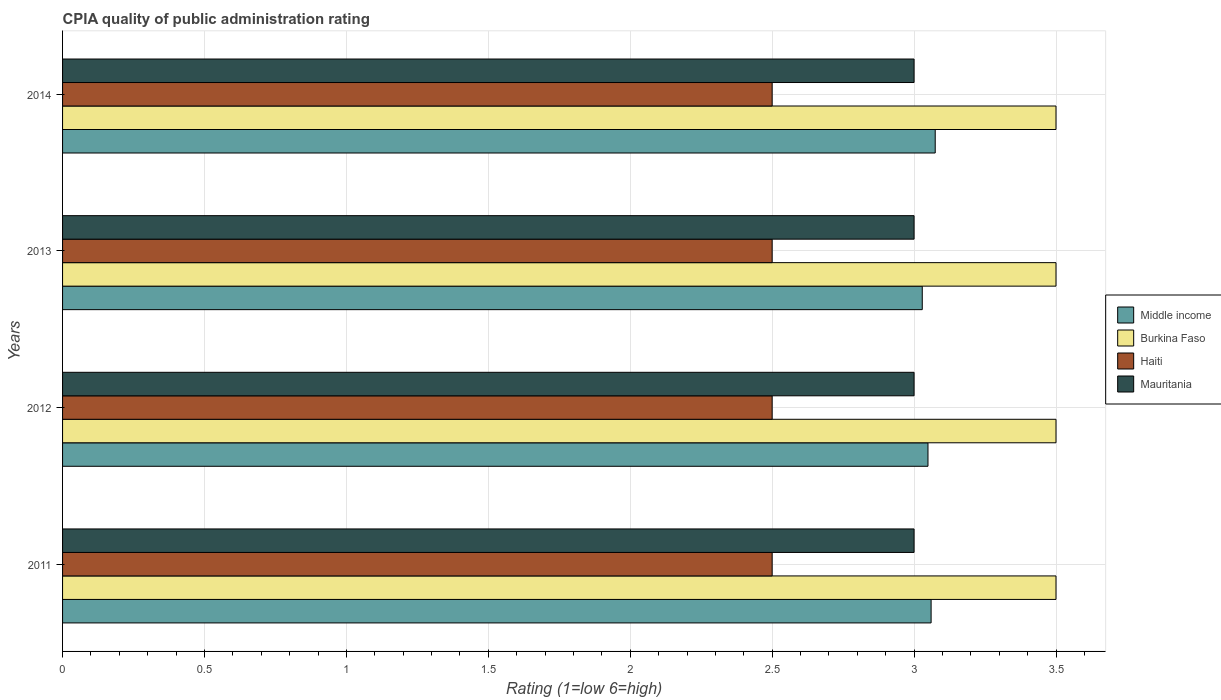How many different coloured bars are there?
Offer a very short reply. 4. How many groups of bars are there?
Give a very brief answer. 4. Are the number of bars on each tick of the Y-axis equal?
Keep it short and to the point. Yes. In how many cases, is the number of bars for a given year not equal to the number of legend labels?
Keep it short and to the point. 0. What is the CPIA rating in Mauritania in 2014?
Ensure brevity in your answer.  3. Across all years, what is the maximum CPIA rating in Haiti?
Keep it short and to the point. 2.5. Across all years, what is the minimum CPIA rating in Middle income?
Your response must be concise. 3.03. What is the total CPIA rating in Middle income in the graph?
Keep it short and to the point. 12.21. What is the difference between the CPIA rating in Middle income in 2013 and the CPIA rating in Burkina Faso in 2012?
Offer a very short reply. -0.47. What is the average CPIA rating in Burkina Faso per year?
Your answer should be very brief. 3.5. In how many years, is the CPIA rating in Mauritania greater than 2.6 ?
Give a very brief answer. 4. Is the difference between the CPIA rating in Burkina Faso in 2012 and 2013 greater than the difference between the CPIA rating in Haiti in 2012 and 2013?
Make the answer very short. No. In how many years, is the CPIA rating in Burkina Faso greater than the average CPIA rating in Burkina Faso taken over all years?
Offer a very short reply. 0. Is the sum of the CPIA rating in Middle income in 2012 and 2014 greater than the maximum CPIA rating in Burkina Faso across all years?
Ensure brevity in your answer.  Yes. What does the 1st bar from the top in 2011 represents?
Provide a short and direct response. Mauritania. What does the 4th bar from the bottom in 2011 represents?
Offer a terse response. Mauritania. Is it the case that in every year, the sum of the CPIA rating in Mauritania and CPIA rating in Middle income is greater than the CPIA rating in Haiti?
Give a very brief answer. Yes. Are the values on the major ticks of X-axis written in scientific E-notation?
Ensure brevity in your answer.  No. Does the graph contain grids?
Your response must be concise. Yes. How many legend labels are there?
Provide a succinct answer. 4. How are the legend labels stacked?
Keep it short and to the point. Vertical. What is the title of the graph?
Offer a very short reply. CPIA quality of public administration rating. Does "East Asia (all income levels)" appear as one of the legend labels in the graph?
Keep it short and to the point. No. What is the Rating (1=low 6=high) in Middle income in 2011?
Offer a very short reply. 3.06. What is the Rating (1=low 6=high) in Mauritania in 2011?
Your answer should be compact. 3. What is the Rating (1=low 6=high) in Middle income in 2012?
Offer a terse response. 3.05. What is the Rating (1=low 6=high) in Middle income in 2013?
Offer a very short reply. 3.03. What is the Rating (1=low 6=high) in Burkina Faso in 2013?
Provide a succinct answer. 3.5. What is the Rating (1=low 6=high) in Middle income in 2014?
Provide a short and direct response. 3.07. What is the Rating (1=low 6=high) in Mauritania in 2014?
Keep it short and to the point. 3. Across all years, what is the maximum Rating (1=low 6=high) of Middle income?
Keep it short and to the point. 3.07. Across all years, what is the minimum Rating (1=low 6=high) of Middle income?
Make the answer very short. 3.03. Across all years, what is the minimum Rating (1=low 6=high) in Burkina Faso?
Keep it short and to the point. 3.5. Across all years, what is the minimum Rating (1=low 6=high) in Mauritania?
Your answer should be compact. 3. What is the total Rating (1=low 6=high) of Middle income in the graph?
Provide a short and direct response. 12.21. What is the total Rating (1=low 6=high) in Burkina Faso in the graph?
Your response must be concise. 14. What is the total Rating (1=low 6=high) of Haiti in the graph?
Ensure brevity in your answer.  10. What is the total Rating (1=low 6=high) in Mauritania in the graph?
Offer a very short reply. 12. What is the difference between the Rating (1=low 6=high) of Middle income in 2011 and that in 2012?
Make the answer very short. 0.01. What is the difference between the Rating (1=low 6=high) in Burkina Faso in 2011 and that in 2012?
Provide a succinct answer. 0. What is the difference between the Rating (1=low 6=high) of Haiti in 2011 and that in 2012?
Ensure brevity in your answer.  0. What is the difference between the Rating (1=low 6=high) of Mauritania in 2011 and that in 2012?
Ensure brevity in your answer.  0. What is the difference between the Rating (1=low 6=high) in Middle income in 2011 and that in 2013?
Your answer should be compact. 0.03. What is the difference between the Rating (1=low 6=high) of Middle income in 2011 and that in 2014?
Provide a succinct answer. -0.01. What is the difference between the Rating (1=low 6=high) in Middle income in 2012 and that in 2013?
Provide a succinct answer. 0.02. What is the difference between the Rating (1=low 6=high) of Burkina Faso in 2012 and that in 2013?
Your response must be concise. 0. What is the difference between the Rating (1=low 6=high) of Haiti in 2012 and that in 2013?
Provide a succinct answer. 0. What is the difference between the Rating (1=low 6=high) in Middle income in 2012 and that in 2014?
Your response must be concise. -0.03. What is the difference between the Rating (1=low 6=high) of Burkina Faso in 2012 and that in 2014?
Your answer should be compact. 0. What is the difference between the Rating (1=low 6=high) of Haiti in 2012 and that in 2014?
Offer a terse response. 0. What is the difference between the Rating (1=low 6=high) of Middle income in 2013 and that in 2014?
Offer a very short reply. -0.05. What is the difference between the Rating (1=low 6=high) in Mauritania in 2013 and that in 2014?
Your response must be concise. 0. What is the difference between the Rating (1=low 6=high) of Middle income in 2011 and the Rating (1=low 6=high) of Burkina Faso in 2012?
Make the answer very short. -0.44. What is the difference between the Rating (1=low 6=high) in Middle income in 2011 and the Rating (1=low 6=high) in Haiti in 2012?
Your answer should be compact. 0.56. What is the difference between the Rating (1=low 6=high) of Burkina Faso in 2011 and the Rating (1=low 6=high) of Mauritania in 2012?
Your answer should be compact. 0.5. What is the difference between the Rating (1=low 6=high) of Middle income in 2011 and the Rating (1=low 6=high) of Burkina Faso in 2013?
Your answer should be very brief. -0.44. What is the difference between the Rating (1=low 6=high) of Middle income in 2011 and the Rating (1=low 6=high) of Haiti in 2013?
Make the answer very short. 0.56. What is the difference between the Rating (1=low 6=high) of Middle income in 2011 and the Rating (1=low 6=high) of Mauritania in 2013?
Make the answer very short. 0.06. What is the difference between the Rating (1=low 6=high) of Burkina Faso in 2011 and the Rating (1=low 6=high) of Mauritania in 2013?
Offer a very short reply. 0.5. What is the difference between the Rating (1=low 6=high) of Haiti in 2011 and the Rating (1=low 6=high) of Mauritania in 2013?
Offer a very short reply. -0.5. What is the difference between the Rating (1=low 6=high) in Middle income in 2011 and the Rating (1=low 6=high) in Burkina Faso in 2014?
Your response must be concise. -0.44. What is the difference between the Rating (1=low 6=high) of Middle income in 2011 and the Rating (1=low 6=high) of Haiti in 2014?
Make the answer very short. 0.56. What is the difference between the Rating (1=low 6=high) in Middle income in 2011 and the Rating (1=low 6=high) in Mauritania in 2014?
Offer a terse response. 0.06. What is the difference between the Rating (1=low 6=high) in Burkina Faso in 2011 and the Rating (1=low 6=high) in Haiti in 2014?
Offer a terse response. 1. What is the difference between the Rating (1=low 6=high) in Burkina Faso in 2011 and the Rating (1=low 6=high) in Mauritania in 2014?
Keep it short and to the point. 0.5. What is the difference between the Rating (1=low 6=high) in Middle income in 2012 and the Rating (1=low 6=high) in Burkina Faso in 2013?
Offer a very short reply. -0.45. What is the difference between the Rating (1=low 6=high) of Middle income in 2012 and the Rating (1=low 6=high) of Haiti in 2013?
Provide a short and direct response. 0.55. What is the difference between the Rating (1=low 6=high) of Middle income in 2012 and the Rating (1=low 6=high) of Mauritania in 2013?
Give a very brief answer. 0.05. What is the difference between the Rating (1=low 6=high) in Burkina Faso in 2012 and the Rating (1=low 6=high) in Mauritania in 2013?
Your response must be concise. 0.5. What is the difference between the Rating (1=low 6=high) of Haiti in 2012 and the Rating (1=low 6=high) of Mauritania in 2013?
Ensure brevity in your answer.  -0.5. What is the difference between the Rating (1=low 6=high) of Middle income in 2012 and the Rating (1=low 6=high) of Burkina Faso in 2014?
Make the answer very short. -0.45. What is the difference between the Rating (1=low 6=high) in Middle income in 2012 and the Rating (1=low 6=high) in Haiti in 2014?
Provide a succinct answer. 0.55. What is the difference between the Rating (1=low 6=high) of Middle income in 2012 and the Rating (1=low 6=high) of Mauritania in 2014?
Keep it short and to the point. 0.05. What is the difference between the Rating (1=low 6=high) in Middle income in 2013 and the Rating (1=low 6=high) in Burkina Faso in 2014?
Ensure brevity in your answer.  -0.47. What is the difference between the Rating (1=low 6=high) of Middle income in 2013 and the Rating (1=low 6=high) of Haiti in 2014?
Your response must be concise. 0.53. What is the difference between the Rating (1=low 6=high) in Middle income in 2013 and the Rating (1=low 6=high) in Mauritania in 2014?
Give a very brief answer. 0.03. What is the difference between the Rating (1=low 6=high) of Burkina Faso in 2013 and the Rating (1=low 6=high) of Haiti in 2014?
Your response must be concise. 1. What is the difference between the Rating (1=low 6=high) of Burkina Faso in 2013 and the Rating (1=low 6=high) of Mauritania in 2014?
Offer a very short reply. 0.5. What is the average Rating (1=low 6=high) in Middle income per year?
Give a very brief answer. 3.05. What is the average Rating (1=low 6=high) of Burkina Faso per year?
Ensure brevity in your answer.  3.5. What is the average Rating (1=low 6=high) in Haiti per year?
Your response must be concise. 2.5. What is the average Rating (1=low 6=high) in Mauritania per year?
Ensure brevity in your answer.  3. In the year 2011, what is the difference between the Rating (1=low 6=high) in Middle income and Rating (1=low 6=high) in Burkina Faso?
Your answer should be compact. -0.44. In the year 2011, what is the difference between the Rating (1=low 6=high) of Middle income and Rating (1=low 6=high) of Haiti?
Your response must be concise. 0.56. In the year 2011, what is the difference between the Rating (1=low 6=high) of Burkina Faso and Rating (1=low 6=high) of Mauritania?
Your answer should be compact. 0.5. In the year 2011, what is the difference between the Rating (1=low 6=high) of Haiti and Rating (1=low 6=high) of Mauritania?
Provide a short and direct response. -0.5. In the year 2012, what is the difference between the Rating (1=low 6=high) of Middle income and Rating (1=low 6=high) of Burkina Faso?
Provide a short and direct response. -0.45. In the year 2012, what is the difference between the Rating (1=low 6=high) in Middle income and Rating (1=low 6=high) in Haiti?
Keep it short and to the point. 0.55. In the year 2012, what is the difference between the Rating (1=low 6=high) in Middle income and Rating (1=low 6=high) in Mauritania?
Your response must be concise. 0.05. In the year 2012, what is the difference between the Rating (1=low 6=high) of Burkina Faso and Rating (1=low 6=high) of Mauritania?
Provide a short and direct response. 0.5. In the year 2013, what is the difference between the Rating (1=low 6=high) of Middle income and Rating (1=low 6=high) of Burkina Faso?
Your answer should be compact. -0.47. In the year 2013, what is the difference between the Rating (1=low 6=high) of Middle income and Rating (1=low 6=high) of Haiti?
Make the answer very short. 0.53. In the year 2013, what is the difference between the Rating (1=low 6=high) of Middle income and Rating (1=low 6=high) of Mauritania?
Keep it short and to the point. 0.03. In the year 2013, what is the difference between the Rating (1=low 6=high) of Burkina Faso and Rating (1=low 6=high) of Haiti?
Offer a terse response. 1. In the year 2014, what is the difference between the Rating (1=low 6=high) of Middle income and Rating (1=low 6=high) of Burkina Faso?
Give a very brief answer. -0.43. In the year 2014, what is the difference between the Rating (1=low 6=high) in Middle income and Rating (1=low 6=high) in Haiti?
Offer a terse response. 0.57. In the year 2014, what is the difference between the Rating (1=low 6=high) of Middle income and Rating (1=low 6=high) of Mauritania?
Your answer should be very brief. 0.07. In the year 2014, what is the difference between the Rating (1=low 6=high) of Burkina Faso and Rating (1=low 6=high) of Mauritania?
Make the answer very short. 0.5. In the year 2014, what is the difference between the Rating (1=low 6=high) in Haiti and Rating (1=low 6=high) in Mauritania?
Offer a terse response. -0.5. What is the ratio of the Rating (1=low 6=high) of Middle income in 2011 to that in 2012?
Offer a terse response. 1. What is the ratio of the Rating (1=low 6=high) in Burkina Faso in 2011 to that in 2012?
Make the answer very short. 1. What is the ratio of the Rating (1=low 6=high) of Mauritania in 2011 to that in 2012?
Offer a very short reply. 1. What is the ratio of the Rating (1=low 6=high) in Middle income in 2011 to that in 2013?
Ensure brevity in your answer.  1.01. What is the ratio of the Rating (1=low 6=high) of Burkina Faso in 2011 to that in 2013?
Ensure brevity in your answer.  1. What is the ratio of the Rating (1=low 6=high) in Haiti in 2011 to that in 2013?
Offer a very short reply. 1. What is the ratio of the Rating (1=low 6=high) in Burkina Faso in 2011 to that in 2014?
Offer a terse response. 1. What is the ratio of the Rating (1=low 6=high) of Haiti in 2011 to that in 2014?
Provide a succinct answer. 1. What is the ratio of the Rating (1=low 6=high) in Burkina Faso in 2012 to that in 2013?
Make the answer very short. 1. What is the ratio of the Rating (1=low 6=high) in Mauritania in 2012 to that in 2013?
Provide a short and direct response. 1. What is the ratio of the Rating (1=low 6=high) of Middle income in 2012 to that in 2014?
Keep it short and to the point. 0.99. What is the ratio of the Rating (1=low 6=high) of Mauritania in 2012 to that in 2014?
Offer a very short reply. 1. What is the ratio of the Rating (1=low 6=high) of Middle income in 2013 to that in 2014?
Your response must be concise. 0.99. What is the difference between the highest and the second highest Rating (1=low 6=high) in Middle income?
Provide a short and direct response. 0.01. What is the difference between the highest and the second highest Rating (1=low 6=high) in Burkina Faso?
Ensure brevity in your answer.  0. What is the difference between the highest and the second highest Rating (1=low 6=high) in Haiti?
Offer a terse response. 0. What is the difference between the highest and the lowest Rating (1=low 6=high) of Middle income?
Offer a terse response. 0.05. What is the difference between the highest and the lowest Rating (1=low 6=high) in Burkina Faso?
Provide a short and direct response. 0. 